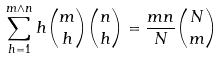<formula> <loc_0><loc_0><loc_500><loc_500>\sum _ { h = 1 } ^ { m \wedge n } h \binom { m } { h } \binom { n } { h } = \frac { m n } { N } \binom { N } { m }</formula> 